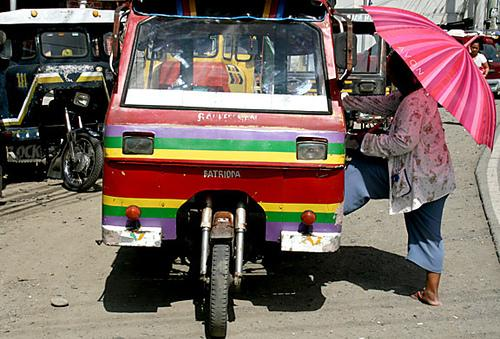What color is at the bottom front of the vehicle in the foreground? Please explain your reasoning. purple. The color is a primary color in the rainbow. 